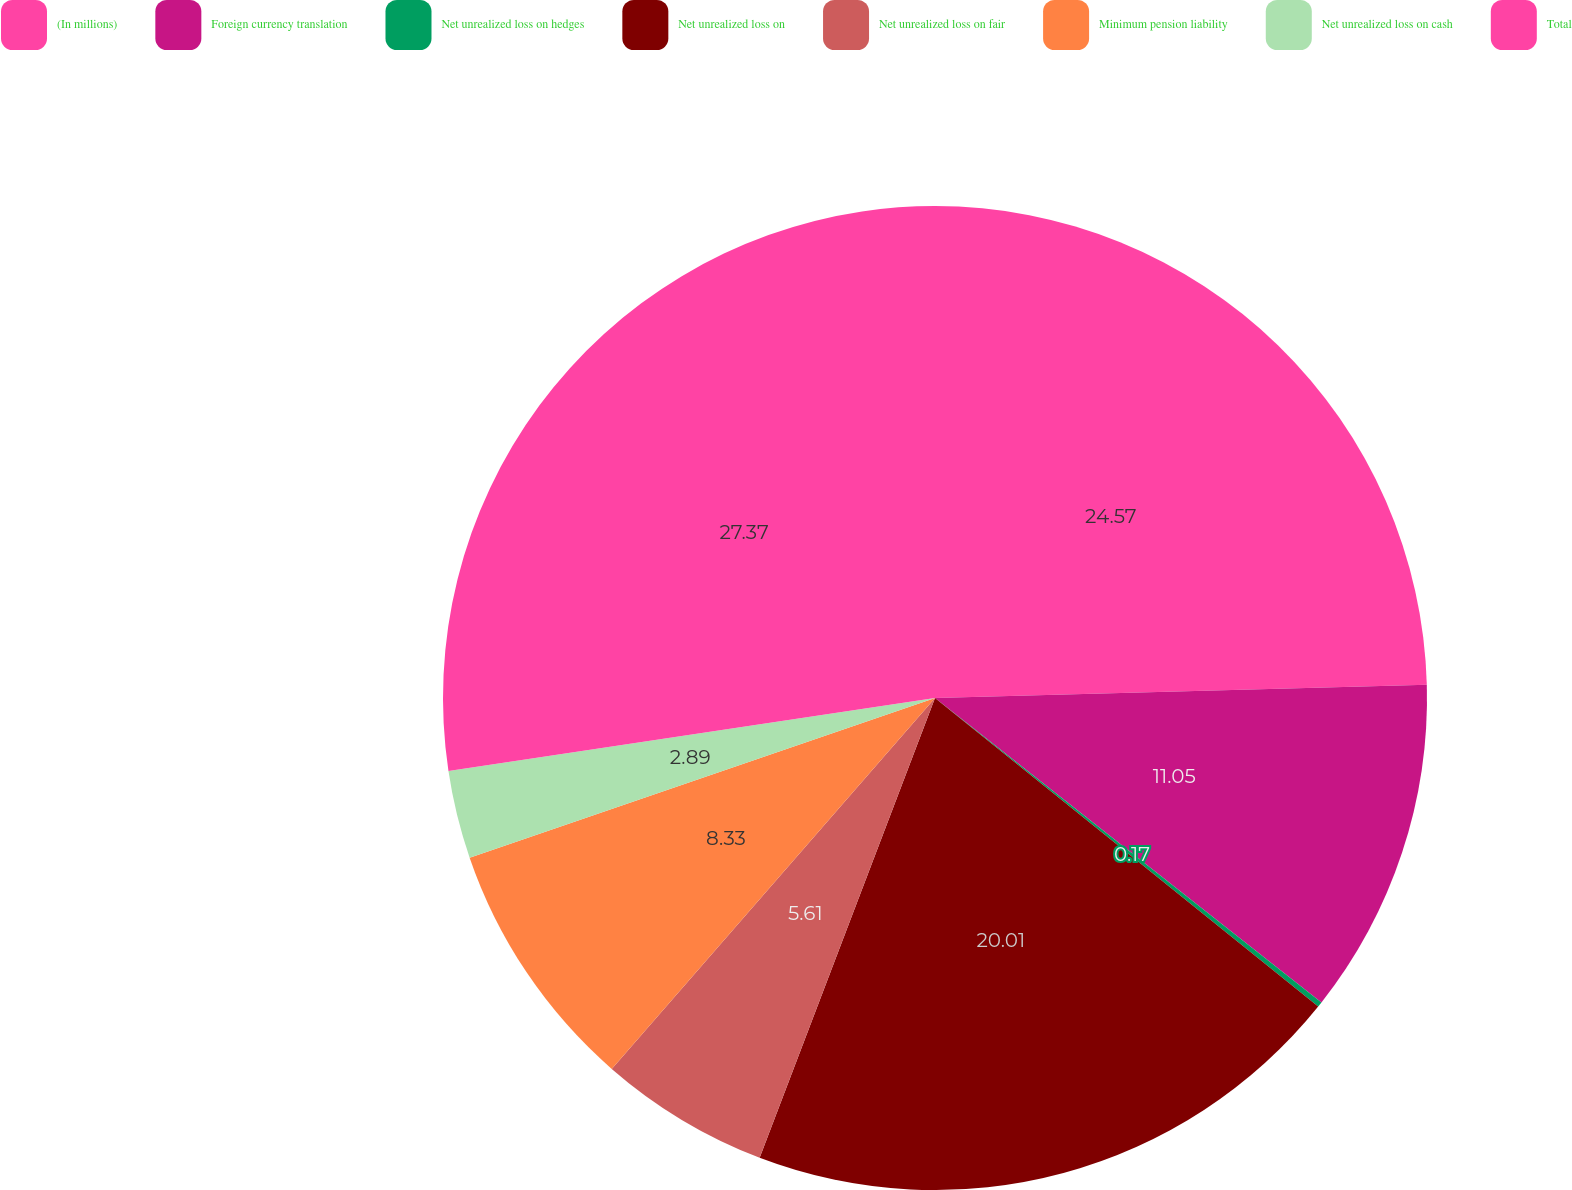<chart> <loc_0><loc_0><loc_500><loc_500><pie_chart><fcel>(In millions)<fcel>Foreign currency translation<fcel>Net unrealized loss on hedges<fcel>Net unrealized loss on<fcel>Net unrealized loss on fair<fcel>Minimum pension liability<fcel>Net unrealized loss on cash<fcel>Total<nl><fcel>24.57%<fcel>11.05%<fcel>0.17%<fcel>20.01%<fcel>5.61%<fcel>8.33%<fcel>2.89%<fcel>27.37%<nl></chart> 